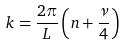Convert formula to latex. <formula><loc_0><loc_0><loc_500><loc_500>k = \frac { 2 \pi } { L } \left ( n + \frac { \nu } { 4 } \right )</formula> 